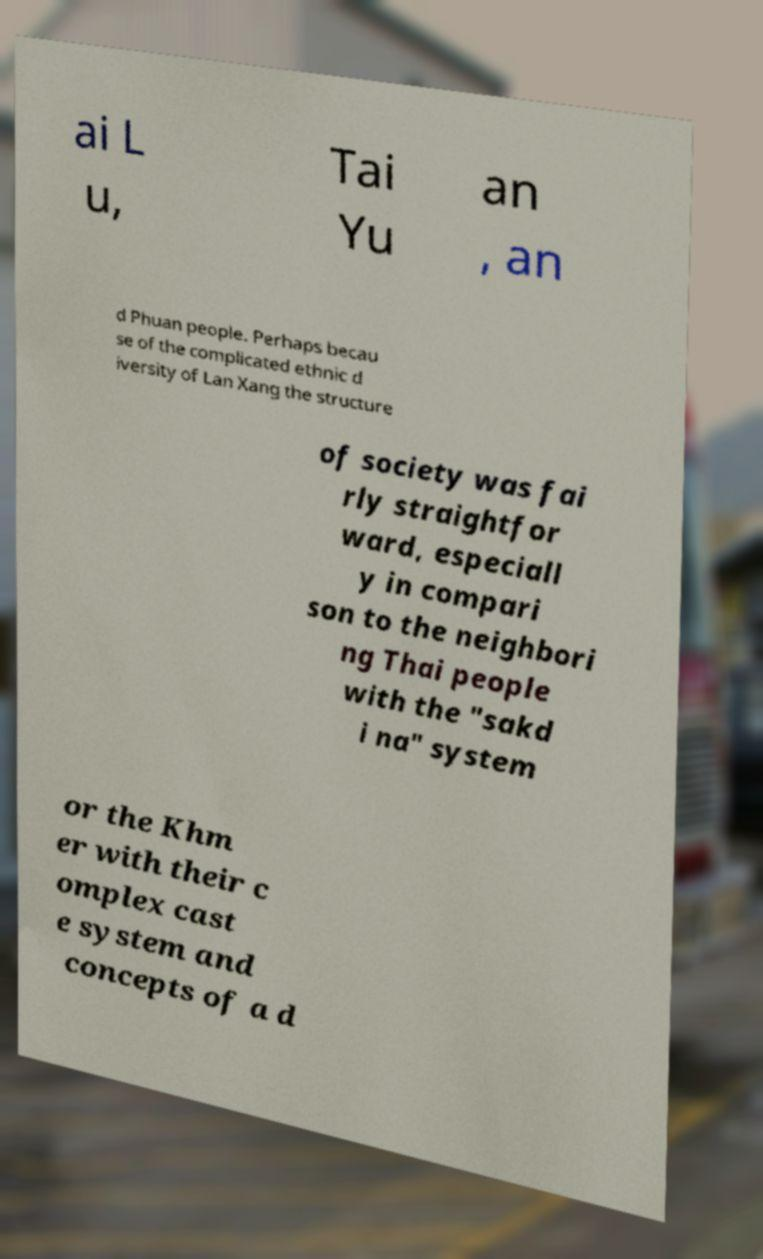There's text embedded in this image that I need extracted. Can you transcribe it verbatim? ai L u, Tai Yu an , an d Phuan people. Perhaps becau se of the complicated ethnic d iversity of Lan Xang the structure of society was fai rly straightfor ward, especiall y in compari son to the neighbori ng Thai people with the "sakd i na" system or the Khm er with their c omplex cast e system and concepts of a d 